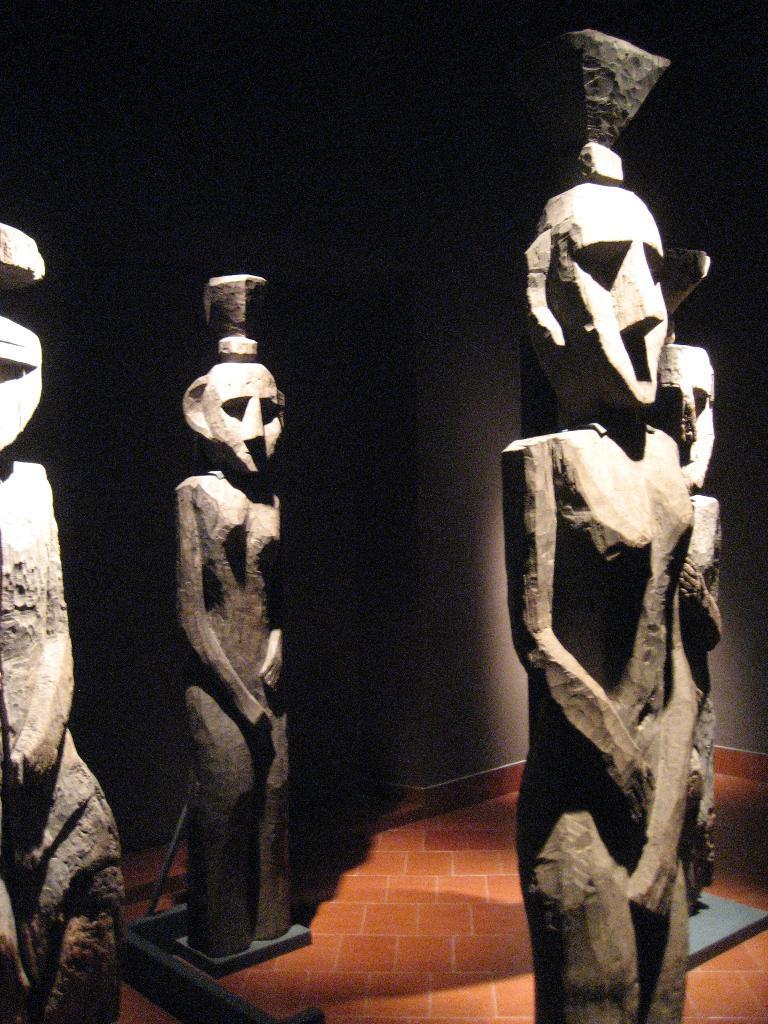Could you give a brief overview of what you see in this image? There are statues. In the background there is a wall. 